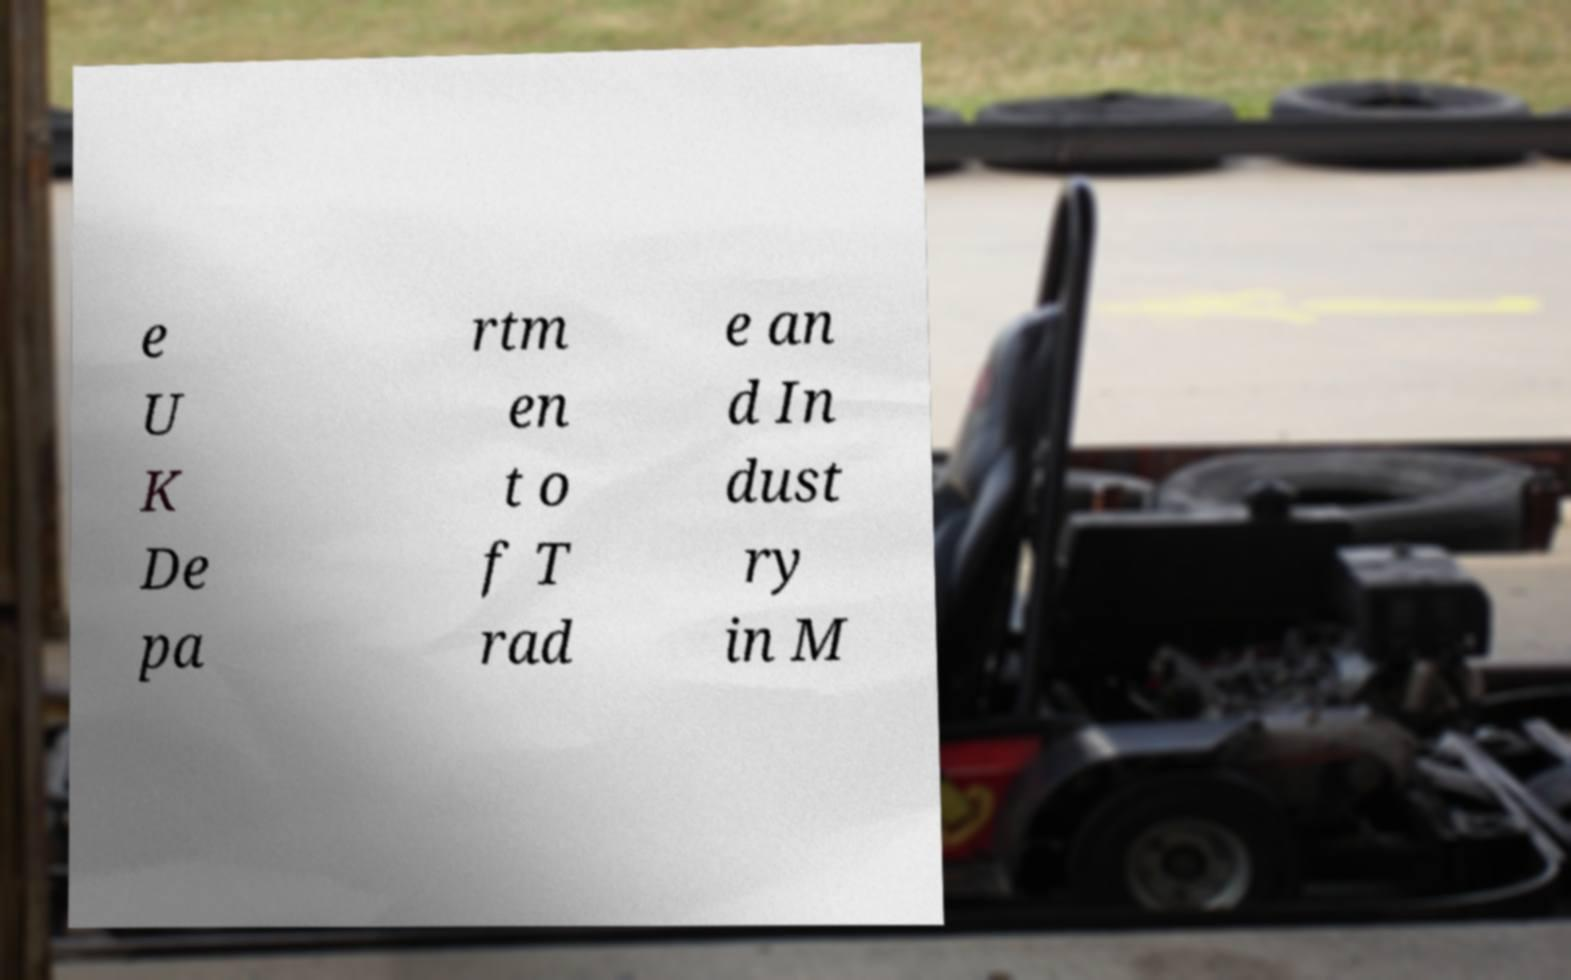Please identify and transcribe the text found in this image. e U K De pa rtm en t o f T rad e an d In dust ry in M 